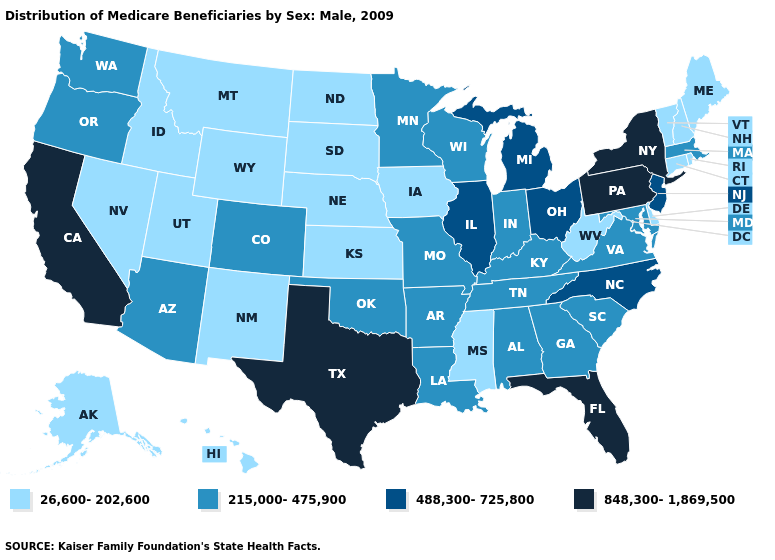Name the states that have a value in the range 215,000-475,900?
Quick response, please. Alabama, Arizona, Arkansas, Colorado, Georgia, Indiana, Kentucky, Louisiana, Maryland, Massachusetts, Minnesota, Missouri, Oklahoma, Oregon, South Carolina, Tennessee, Virginia, Washington, Wisconsin. What is the value of Connecticut?
Short answer required. 26,600-202,600. Does Delaware have the lowest value in the USA?
Keep it brief. Yes. Name the states that have a value in the range 488,300-725,800?
Quick response, please. Illinois, Michigan, New Jersey, North Carolina, Ohio. What is the value of Indiana?
Answer briefly. 215,000-475,900. Name the states that have a value in the range 26,600-202,600?
Keep it brief. Alaska, Connecticut, Delaware, Hawaii, Idaho, Iowa, Kansas, Maine, Mississippi, Montana, Nebraska, Nevada, New Hampshire, New Mexico, North Dakota, Rhode Island, South Dakota, Utah, Vermont, West Virginia, Wyoming. Among the states that border Missouri , which have the highest value?
Concise answer only. Illinois. What is the value of Alaska?
Short answer required. 26,600-202,600. Among the states that border Nevada , which have the lowest value?
Quick response, please. Idaho, Utah. Among the states that border Tennessee , which have the lowest value?
Keep it brief. Mississippi. Does Minnesota have a higher value than Nebraska?
Be succinct. Yes. Among the states that border New Jersey , which have the lowest value?
Short answer required. Delaware. Does Maryland have the highest value in the USA?
Answer briefly. No. Name the states that have a value in the range 26,600-202,600?
Write a very short answer. Alaska, Connecticut, Delaware, Hawaii, Idaho, Iowa, Kansas, Maine, Mississippi, Montana, Nebraska, Nevada, New Hampshire, New Mexico, North Dakota, Rhode Island, South Dakota, Utah, Vermont, West Virginia, Wyoming. Which states have the lowest value in the MidWest?
Keep it brief. Iowa, Kansas, Nebraska, North Dakota, South Dakota. 